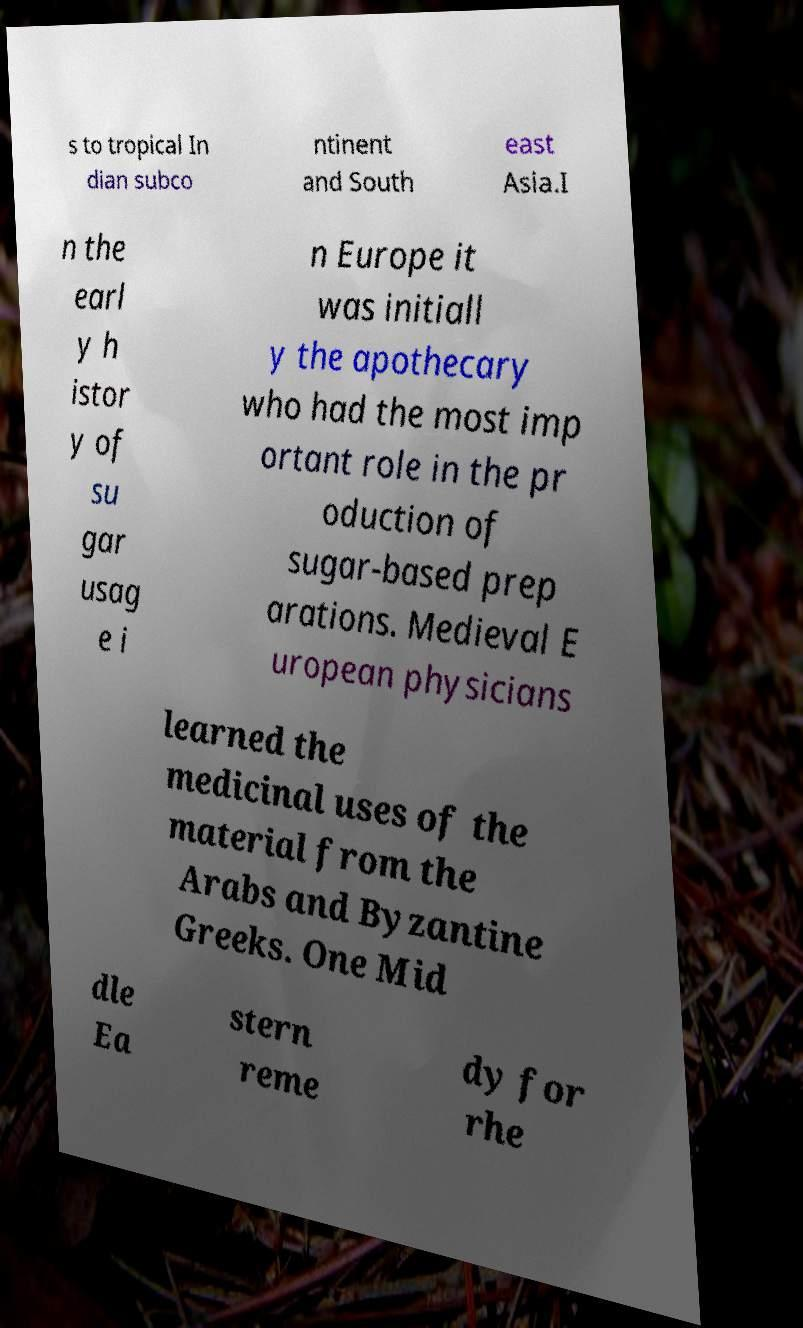Could you assist in decoding the text presented in this image and type it out clearly? s to tropical In dian subco ntinent and South east Asia.I n the earl y h istor y of su gar usag e i n Europe it was initiall y the apothecary who had the most imp ortant role in the pr oduction of sugar-based prep arations. Medieval E uropean physicians learned the medicinal uses of the material from the Arabs and Byzantine Greeks. One Mid dle Ea stern reme dy for rhe 